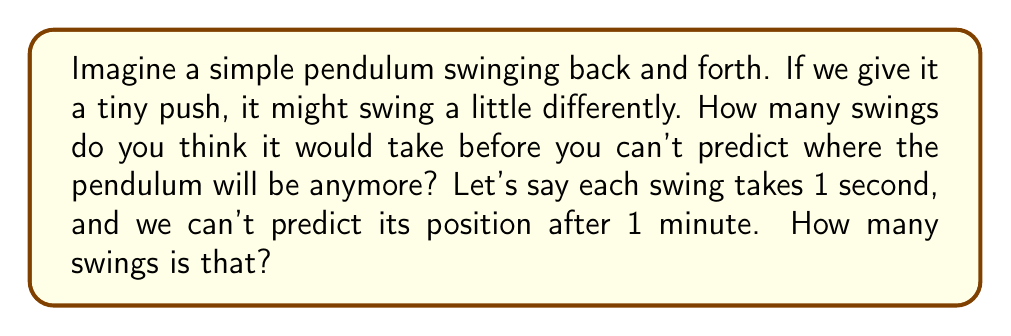Teach me how to tackle this problem. Let's break this down step-by-step:

1. First, we need to understand what the question is asking. We're looking for the number of swings that occur in 1 minute, after which we can't predict the pendulum's position.

2. We're told that each swing takes 1 second. This is important information!

3. Now, we need to convert 1 minute into seconds:
   $$ 1 \text{ minute} = 60 \text{ seconds} $$

4. Since each swing takes 1 second, the number of swings in 1 minute will be equal to the number of seconds in a minute:
   $$ \text{Number of swings} = 60 $$

5. This concept is related to chaos theory. Even tiny changes in the initial conditions (like our small push) can lead to big differences over time. After about 60 swings, the pendulum's motion becomes "chaotic" and unpredictable!
Answer: 60 swings 